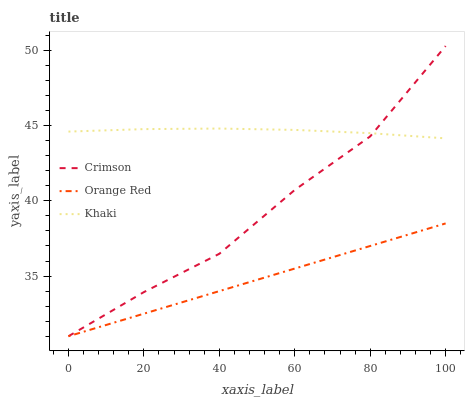Does Orange Red have the minimum area under the curve?
Answer yes or no. Yes. Does Khaki have the maximum area under the curve?
Answer yes or no. Yes. Does Khaki have the minimum area under the curve?
Answer yes or no. No. Does Orange Red have the maximum area under the curve?
Answer yes or no. No. Is Orange Red the smoothest?
Answer yes or no. Yes. Is Crimson the roughest?
Answer yes or no. Yes. Is Khaki the smoothest?
Answer yes or no. No. Is Khaki the roughest?
Answer yes or no. No. Does Crimson have the lowest value?
Answer yes or no. Yes. Does Khaki have the lowest value?
Answer yes or no. No. Does Crimson have the highest value?
Answer yes or no. Yes. Does Khaki have the highest value?
Answer yes or no. No. Is Orange Red less than Khaki?
Answer yes or no. Yes. Is Khaki greater than Orange Red?
Answer yes or no. Yes. Does Crimson intersect Khaki?
Answer yes or no. Yes. Is Crimson less than Khaki?
Answer yes or no. No. Is Crimson greater than Khaki?
Answer yes or no. No. Does Orange Red intersect Khaki?
Answer yes or no. No. 